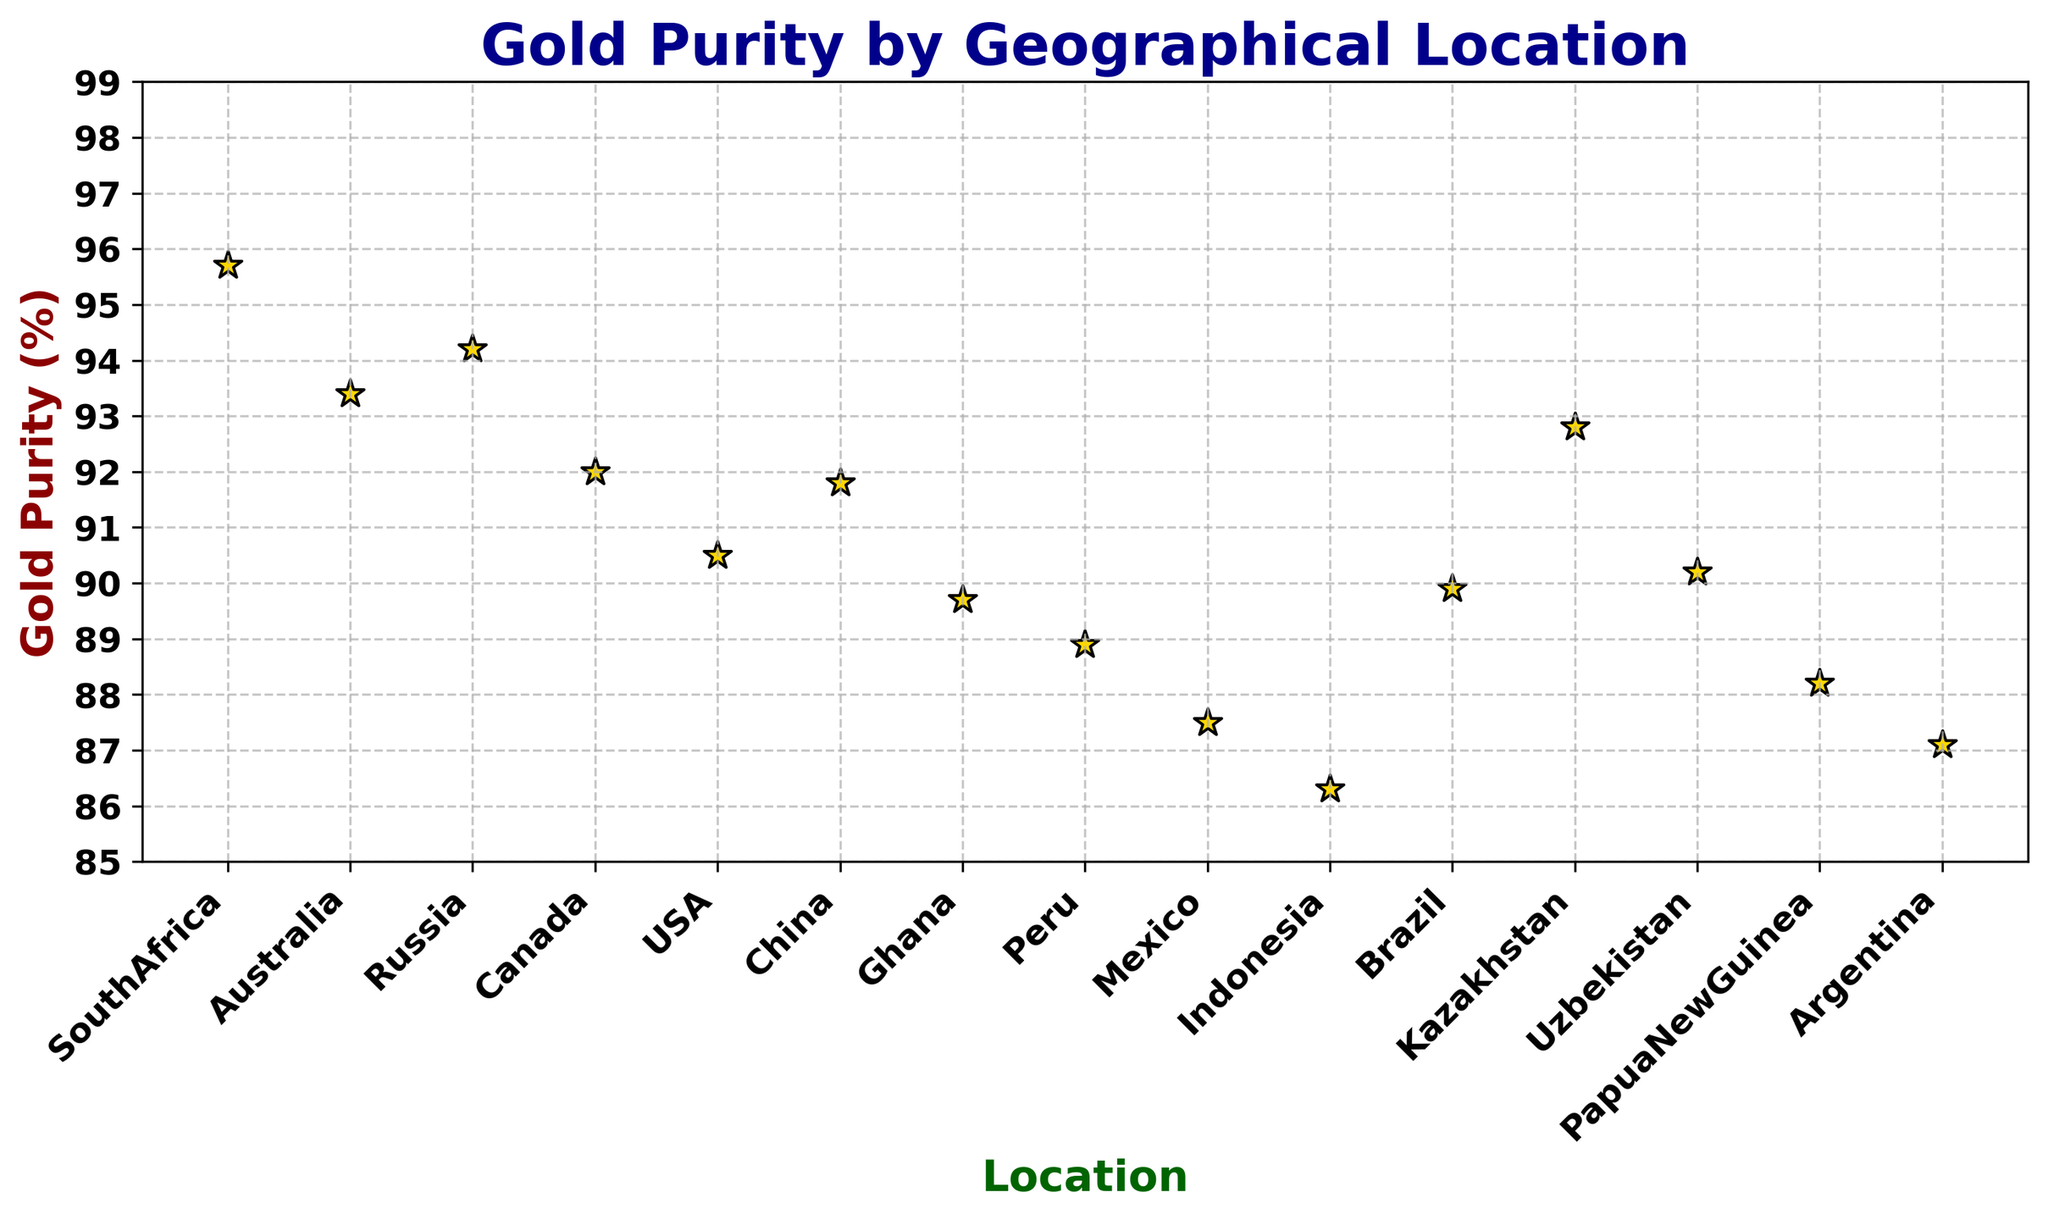Which location has the highest gold purity? Examine the vertical position of the points on the scatter plot. The highest point represents the highest gold purity. South Africa has the highest gold purity at 95.7%.
Answer: South Africa Which location has the lowest gold purity? Look for the lowest point on the scatter plot, which indicates the lowest gold purity. Indonesia has the lowest gold purity at 86.3%.
Answer: Indonesia What is the difference in gold purity between the highest and lowest purity locations? Determine the highest purity (95.7% from South Africa) and the lowest purity (86.3% from Indonesia). Subtract the lowest from the highest: 95.7% - 86.3% = 9.4%.
Answer: 9.4% Which two locations have gold purity closest to each other? Find pairs of points on the scatter plot that are close horizontally (indicating proximity in gold purity percentage). Canada (92.0%) and Kazakhstan (92.8%) are close, with a difference of 0.8%.
Answer: Canada and Kazakhstan Which region shows a gold purity greater than 90 but less than 92? Check the points vertically between 90% and 92% on the scatter plot. USA (90.5%), China (91.8%), and Uzbekistan (90.2%) fit within this range.
Answer: USA, China, and Uzbekistan How many locations have gold purity above 93%? Identify the points that are above the 93% line on the scatter plot. South Africa, Australia, and Russia are above 93%. There are 3 locations.
Answer: 3 What is the average gold purity of South American countries on this list? Identify South American countries and their gold purity: Peru (88.9%), Brazil (89.9%), and Argentina (87.1%). Find the average: (88.9% + 89.9% + 87.1%) / 3 = 88.63%.
Answer: 88.63% Which location has nearly 90% gold purity? Look for a point on the scatter plot close to the 90% mark. Uzbekistan has a gold purity of 90.2%, closest to 90%.
Answer: Uzbekistan What is the difference in gold purity between Canada and Papua New Guinea? Check the gold purity values: Canada (92.0%) and Papua New Guinea (88.2%). Subtract the lower value from the higher value: 92.0% - 88.2% = 3.8%.
Answer: 3.8% Which has a higher gold purity: Australia or Russia? Compare the vertical positions of Australia (93.4%) and Russia (94.2%). Russia is higher.
Answer: Russia 